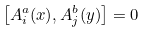Convert formula to latex. <formula><loc_0><loc_0><loc_500><loc_500>\left [ A _ { i } ^ { a } ( { x } ) , A _ { j } ^ { b } ( { y } ) \right ] = 0</formula> 